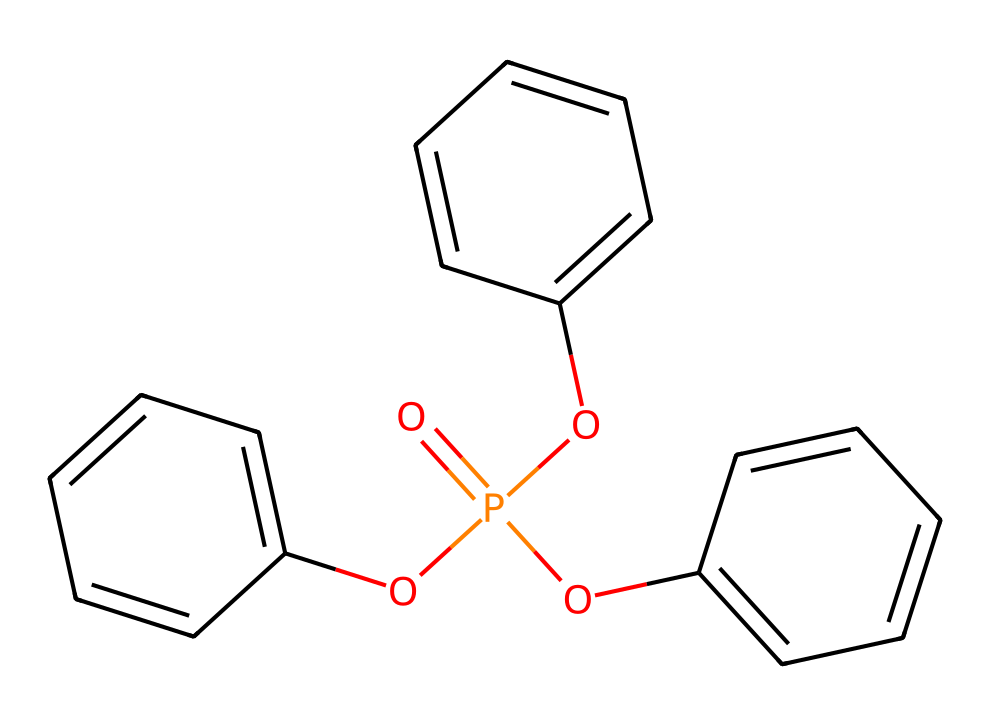What is the main phosphorus atom in this molecule? The SMILES representation shows "O=P" indicating that phosphorus is the central atom attached to oxygen atoms. The presence of "P" confirms that phosphorus is the main atom.
Answer: phosphorus How many benzene rings are present in this compound? By analyzing the structure in the SMILES notation, we see three occurrences of "c" in separate groups, indicating three benzene rings attached to the phosphorus atom via oxygen linkages.
Answer: three What type of functional groups are present in the compound? The "Oc" part of the SMILES indicates the presence of ether functional groups (-O-) connecting the benzene rings to the phosphorus atom, showcasing that these are ether linkages.
Answer: ether What is the oxidation state of phosphorus in this compound? The phosphorus atom is bonded to four oxygen atoms (one with double bond) as indicated by "O=P(O...)", resulting in an oxidation state of +5 for phosphorus in this structure.
Answer: +5 What might be the solubility of this phosphorus compound in water? With the presence of multiple oxygen atoms attached to phosphorus and aromatic rings, such a structure tends to have polar character, suggesting a higher likelihood of solubility in polar solvents like water.
Answer: soluble What is the role of phosphorus in inks historically? Phosphorus compounds are used to enhance color stability and longevity in inks, making them preferable for preserving documents like Freud's manuscripts.
Answer: preservation 